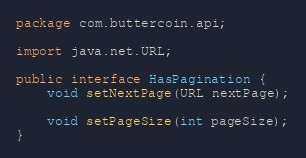<code> <loc_0><loc_0><loc_500><loc_500><_Java_>package com.buttercoin.api;

import java.net.URL;

public interface HasPagination {
    void setNextPage(URL nextPage);

    void setPageSize(int pageSize);
}
</code> 